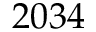Convert formula to latex. <formula><loc_0><loc_0><loc_500><loc_500>2 0 3 4</formula> 